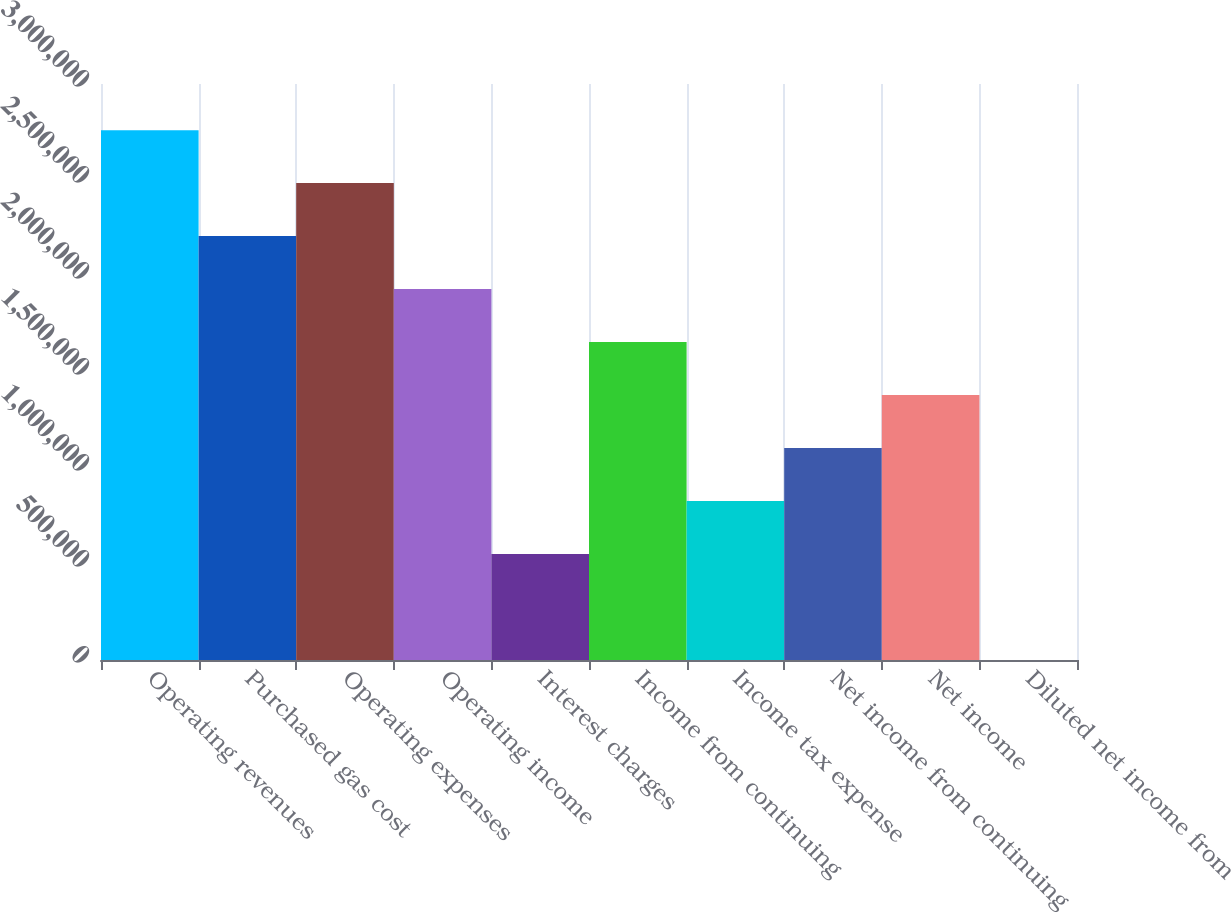Convert chart. <chart><loc_0><loc_0><loc_500><loc_500><bar_chart><fcel>Operating revenues<fcel>Purchased gas cost<fcel>Operating expenses<fcel>Operating income<fcel>Interest charges<fcel>Income from continuing<fcel>Income tax expense<fcel>Net income from continuing<fcel>Net income<fcel>Diluted net income from<nl><fcel>2.75974e+06<fcel>2.20779e+06<fcel>2.48376e+06<fcel>1.93182e+06<fcel>551950<fcel>1.65584e+06<fcel>827923<fcel>1.1039e+06<fcel>1.37987e+06<fcel>3.6<nl></chart> 